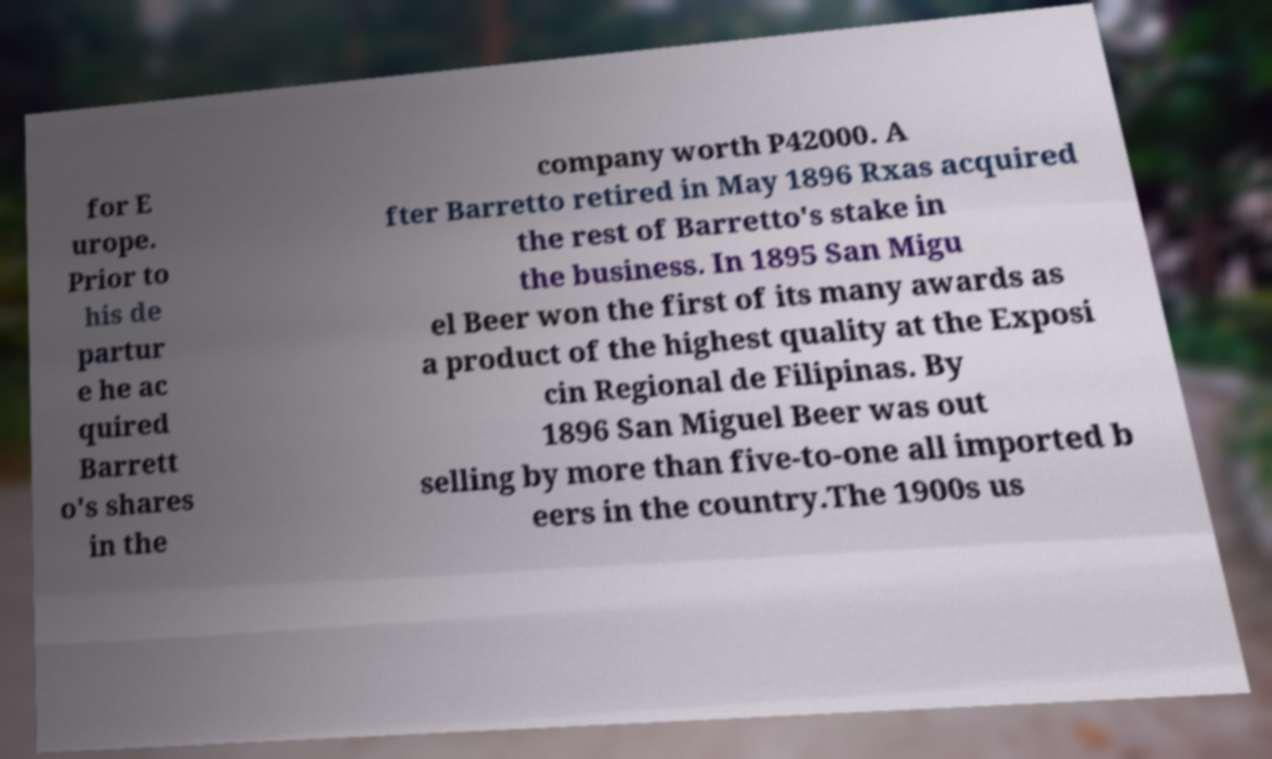Please identify and transcribe the text found in this image. for E urope. Prior to his de partur e he ac quired Barrett o's shares in the company worth P42000. A fter Barretto retired in May 1896 Rxas acquired the rest of Barretto's stake in the business. In 1895 San Migu el Beer won the first of its many awards as a product of the highest quality at the Exposi cin Regional de Filipinas. By 1896 San Miguel Beer was out selling by more than five-to-one all imported b eers in the country.The 1900s us 